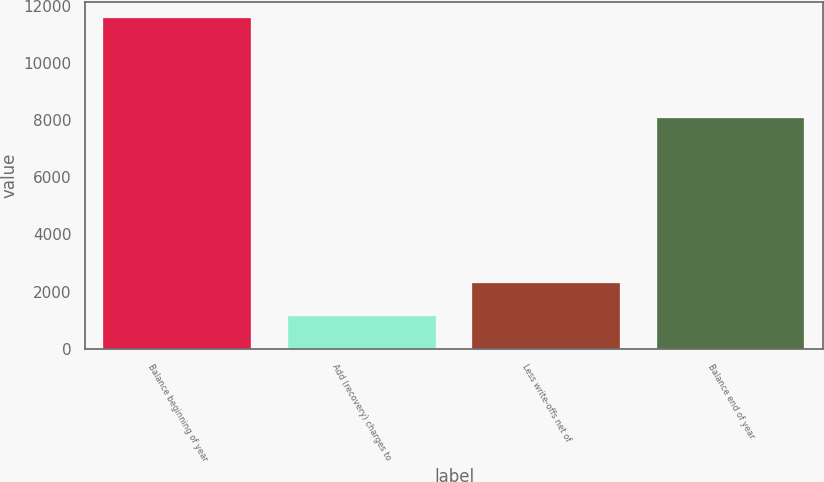Convert chart. <chart><loc_0><loc_0><loc_500><loc_500><bar_chart><fcel>Balance beginning of year<fcel>Add (recovery) charges to<fcel>Less write-offs net of<fcel>Balance end of year<nl><fcel>11559<fcel>1165<fcel>2311<fcel>8083<nl></chart> 